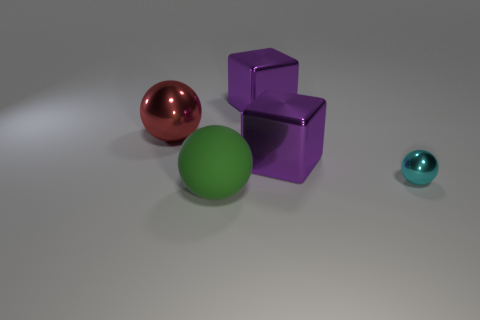Add 1 tiny gray matte objects. How many objects exist? 6 Subtract all spheres. How many objects are left? 2 Subtract 0 yellow blocks. How many objects are left? 5 Subtract all small cyan metal things. Subtract all cyan shiny objects. How many objects are left? 3 Add 5 metal blocks. How many metal blocks are left? 7 Add 1 big gray matte cylinders. How many big gray matte cylinders exist? 1 